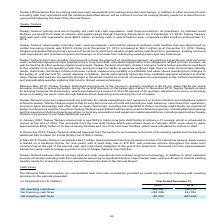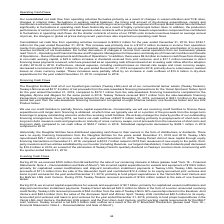From Teekay Corporation's financial document, How much was Consolidated net cash flow from operating activities for the year ended December 31, 2019 and 2018 respectively? The document shows two values: $383.3 million and $182.1 million. From the document: "million for the year ended December 31, 2019, from $182.1 million for the year ended December 31, 2018. This increase was primarily due to a $127.2 mi..." Also, What led to increase in Consolidated net cash flow from operating activities for the year ended December 31, 2019? primarily due to a $127.2 million increase in income from operations mainly from operations (before depreciation, amortization, asset impairments, loss on sale of vessels and the amortization of in-process revenue contracts) of our businesses.. The document states: "he year ended December 31, 2018. This increase was primarily due to a $127.2 million increase in income from operations mainly from operations (before..." Also, How much was received from Brookfield for the sale of interests in Altera during 2019? According to the financial document, $100 million. The relevant text states: "During 2019, we received $100 million from Brookfield for the sale of our remaining interests in Altera (please read "Item 18 – Financial..." Also, can you calculate: What is the change in Net operating cash flows from Year Ended December 31, 2019 to December 31, 2018? Based on the calculation: 383,306-182,135, the result is 201171 (in thousands). This is based on the information: "Net operating cash flows 383,306 182,135 Net operating cash flows 383,306 182,135..." The key data points involved are: 182,135, 383,306. Also, can you calculate: What is the change in Net financing cash flows from Year Ended December 31, 2019 to December 31, 2018? Based on the calculation: -382,229-434,786, the result is -817015 (in thousands). This is based on the information: "Net financing cash flows (382,229) 434,786 Net financing cash flows (382,229) 434,786..." The key data points involved are: 382,229, 434,786. Also, can you calculate: What is the change in Net investing cash flows from Year Ended December 31, 2019 to December 31, 2018? Based on the calculation: -50,391-(-663,456), the result is 613065 (in thousands). This is based on the information: "Net investing cash flows (50,391) (663,456) Net investing cash flows (50,391) (663,456)..." The key data points involved are: 50,391, 663,456. 